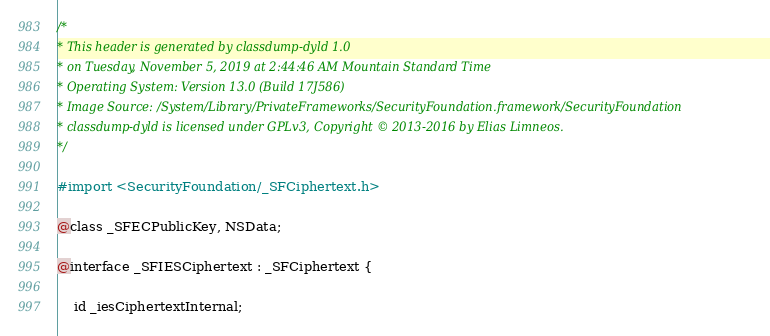Convert code to text. <code><loc_0><loc_0><loc_500><loc_500><_C_>/*
* This header is generated by classdump-dyld 1.0
* on Tuesday, November 5, 2019 at 2:44:46 AM Mountain Standard Time
* Operating System: Version 13.0 (Build 17J586)
* Image Source: /System/Library/PrivateFrameworks/SecurityFoundation.framework/SecurityFoundation
* classdump-dyld is licensed under GPLv3, Copyright © 2013-2016 by Elias Limneos.
*/

#import <SecurityFoundation/_SFCiphertext.h>

@class _SFECPublicKey, NSData;

@interface _SFIESCiphertext : _SFCiphertext {

	id _iesCiphertextInternal;
</code> 